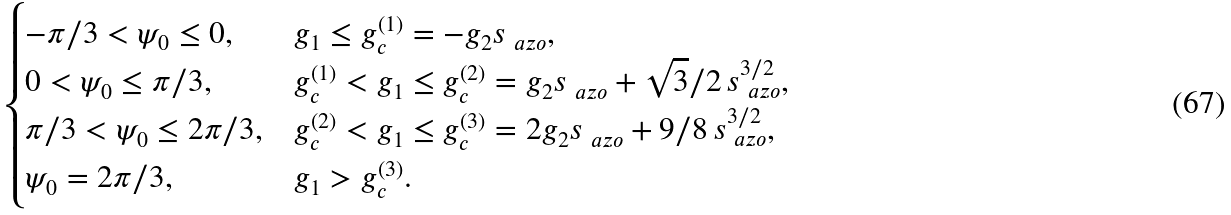<formula> <loc_0><loc_0><loc_500><loc_500>\begin{cases} - \pi / 3 < \psi _ { 0 } \leq 0 , & g _ { 1 } \leq g _ { c } ^ { ( 1 ) } = - g _ { 2 } s _ { \ a z o } , \\ 0 < \psi _ { 0 } \leq \pi / 3 , & g _ { c } ^ { ( 1 ) } < g _ { 1 } \leq g _ { c } ^ { ( 2 ) } = g _ { 2 } s _ { \ a z o } + \sqrt { 3 } / 2 \, s _ { \ a z o } ^ { 3 / 2 } , \\ \pi / 3 < \psi _ { 0 } \leq 2 \pi / 3 , & g _ { c } ^ { ( 2 ) } < g _ { 1 } \leq g _ { c } ^ { ( 3 ) } = 2 g _ { 2 } s _ { \ a z o } + 9 / 8 \, s _ { \ a z o } ^ { 3 / 2 } , \\ \psi _ { 0 } = 2 \pi / 3 , & g _ { 1 } > g _ { c } ^ { ( 3 ) } . \\ \end{cases}</formula> 